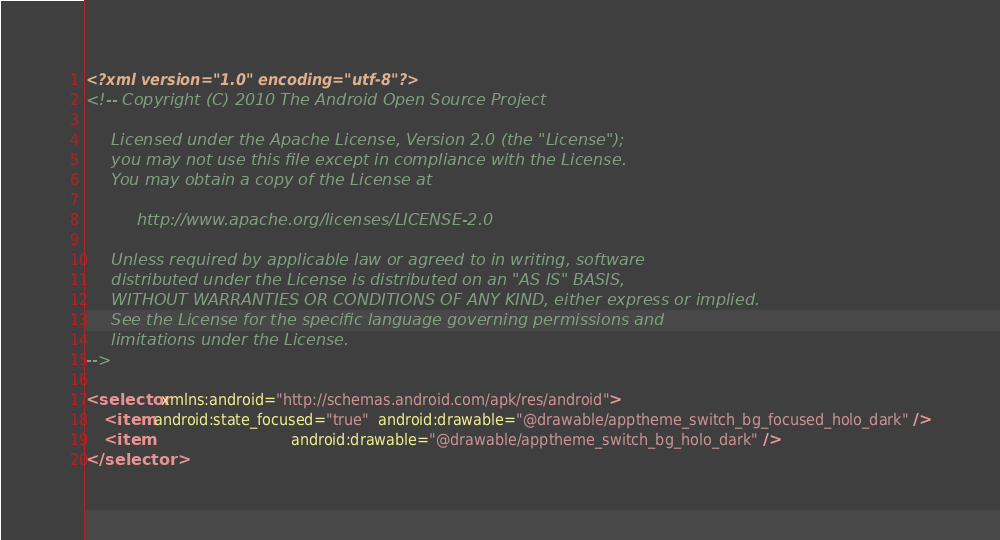Convert code to text. <code><loc_0><loc_0><loc_500><loc_500><_XML_><?xml version="1.0" encoding="utf-8"?>
<!-- Copyright (C) 2010 The Android Open Source Project

     Licensed under the Apache License, Version 2.0 (the "License");
     you may not use this file except in compliance with the License.
     You may obtain a copy of the License at

          http://www.apache.org/licenses/LICENSE-2.0

     Unless required by applicable law or agreed to in writing, software
     distributed under the License is distributed on an "AS IS" BASIS,
     WITHOUT WARRANTIES OR CONDITIONS OF ANY KIND, either express or implied.
     See the License for the specific language governing permissions and
     limitations under the License.
-->

<selector xmlns:android="http://schemas.android.com/apk/res/android">
    <item android:state_focused="true"  android:drawable="@drawable/apptheme_switch_bg_focused_holo_dark" />
    <item                               android:drawable="@drawable/apptheme_switch_bg_holo_dark" />
</selector>
</code> 